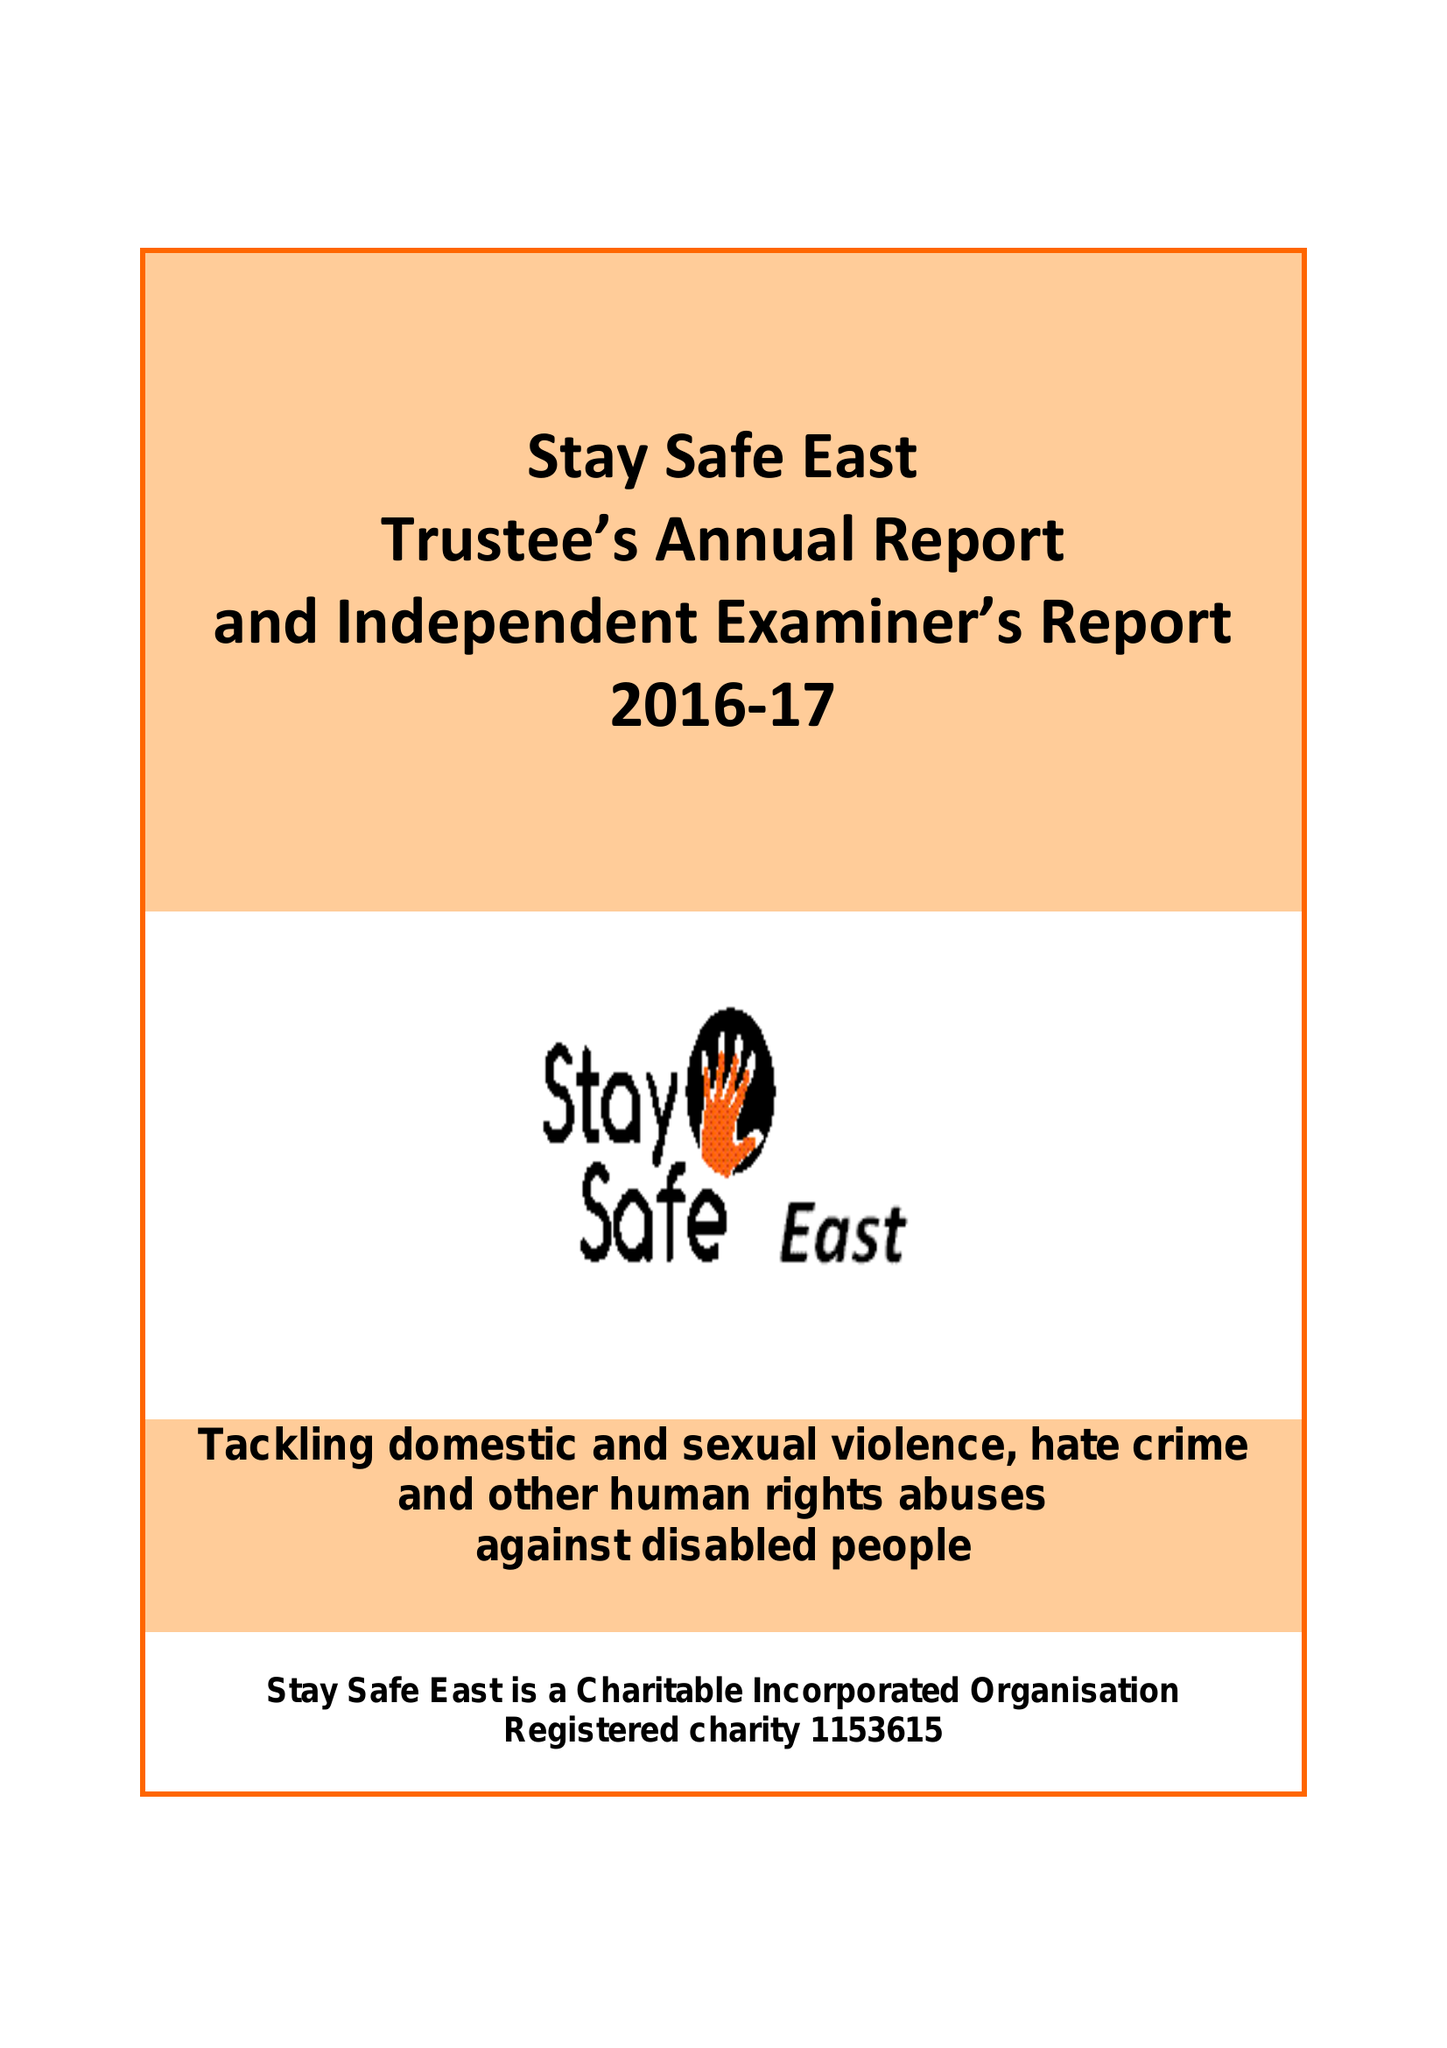What is the value for the charity_name?
Answer the question using a single word or phrase. Stay Safe East 